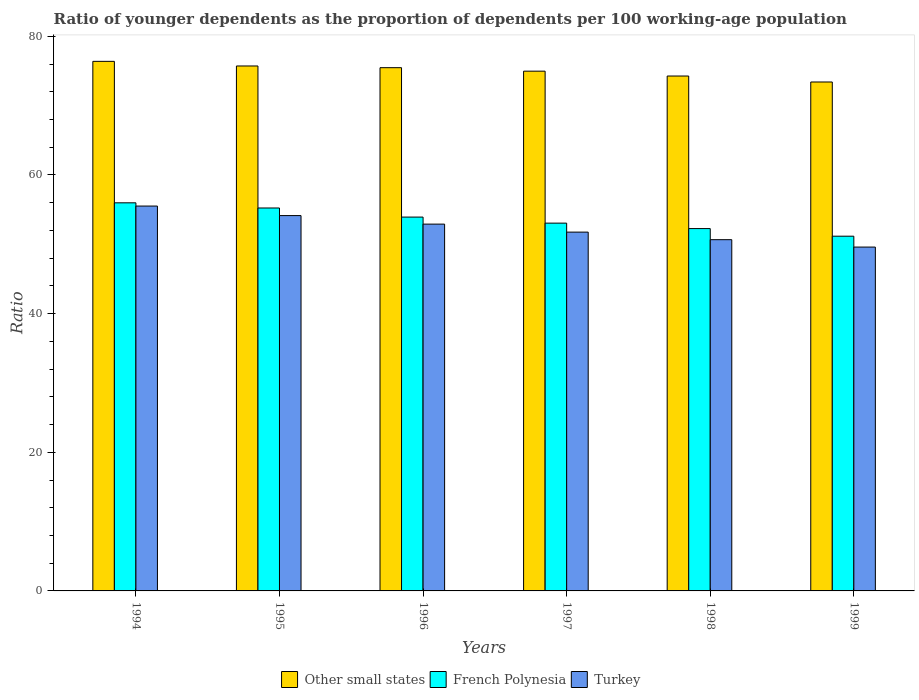How many groups of bars are there?
Offer a very short reply. 6. Are the number of bars on each tick of the X-axis equal?
Your response must be concise. Yes. How many bars are there on the 1st tick from the left?
Your answer should be compact. 3. What is the label of the 1st group of bars from the left?
Offer a terse response. 1994. In how many cases, is the number of bars for a given year not equal to the number of legend labels?
Offer a terse response. 0. What is the age dependency ratio(young) in Turkey in 1997?
Give a very brief answer. 51.76. Across all years, what is the maximum age dependency ratio(young) in Other small states?
Offer a terse response. 76.39. Across all years, what is the minimum age dependency ratio(young) in Other small states?
Keep it short and to the point. 73.42. In which year was the age dependency ratio(young) in French Polynesia minimum?
Keep it short and to the point. 1999. What is the total age dependency ratio(young) in French Polynesia in the graph?
Make the answer very short. 321.65. What is the difference between the age dependency ratio(young) in Other small states in 1995 and that in 1998?
Offer a terse response. 1.45. What is the difference between the age dependency ratio(young) in Turkey in 1998 and the age dependency ratio(young) in Other small states in 1999?
Offer a very short reply. -22.75. What is the average age dependency ratio(young) in Turkey per year?
Offer a very short reply. 52.43. In the year 1996, what is the difference between the age dependency ratio(young) in French Polynesia and age dependency ratio(young) in Other small states?
Keep it short and to the point. -21.55. What is the ratio of the age dependency ratio(young) in Other small states in 1996 to that in 1997?
Your response must be concise. 1.01. What is the difference between the highest and the second highest age dependency ratio(young) in Other small states?
Keep it short and to the point. 0.67. What is the difference between the highest and the lowest age dependency ratio(young) in French Polynesia?
Offer a very short reply. 4.81. Is the sum of the age dependency ratio(young) in French Polynesia in 1996 and 1999 greater than the maximum age dependency ratio(young) in Turkey across all years?
Keep it short and to the point. Yes. What does the 1st bar from the left in 1994 represents?
Offer a terse response. Other small states. What does the 1st bar from the right in 1994 represents?
Make the answer very short. Turkey. Is it the case that in every year, the sum of the age dependency ratio(young) in Other small states and age dependency ratio(young) in French Polynesia is greater than the age dependency ratio(young) in Turkey?
Give a very brief answer. Yes. Are all the bars in the graph horizontal?
Provide a succinct answer. No. What is the difference between two consecutive major ticks on the Y-axis?
Your answer should be compact. 20. Does the graph contain any zero values?
Your answer should be very brief. No. Does the graph contain grids?
Ensure brevity in your answer.  No. Where does the legend appear in the graph?
Your answer should be compact. Bottom center. How are the legend labels stacked?
Provide a short and direct response. Horizontal. What is the title of the graph?
Your response must be concise. Ratio of younger dependents as the proportion of dependents per 100 working-age population. What is the label or title of the Y-axis?
Provide a short and direct response. Ratio. What is the Ratio of Other small states in 1994?
Provide a succinct answer. 76.39. What is the Ratio in French Polynesia in 1994?
Your answer should be very brief. 55.99. What is the Ratio of Turkey in 1994?
Your response must be concise. 55.52. What is the Ratio of Other small states in 1995?
Offer a terse response. 75.73. What is the Ratio of French Polynesia in 1995?
Make the answer very short. 55.24. What is the Ratio in Turkey in 1995?
Your answer should be compact. 54.14. What is the Ratio of Other small states in 1996?
Give a very brief answer. 75.48. What is the Ratio of French Polynesia in 1996?
Offer a very short reply. 53.93. What is the Ratio in Turkey in 1996?
Your answer should be very brief. 52.91. What is the Ratio in Other small states in 1997?
Offer a very short reply. 74.98. What is the Ratio of French Polynesia in 1997?
Provide a short and direct response. 53.06. What is the Ratio in Turkey in 1997?
Provide a short and direct response. 51.76. What is the Ratio of Other small states in 1998?
Keep it short and to the point. 74.28. What is the Ratio of French Polynesia in 1998?
Offer a terse response. 52.27. What is the Ratio of Turkey in 1998?
Your answer should be very brief. 50.67. What is the Ratio in Other small states in 1999?
Provide a short and direct response. 73.42. What is the Ratio in French Polynesia in 1999?
Offer a terse response. 51.17. What is the Ratio of Turkey in 1999?
Make the answer very short. 49.6. Across all years, what is the maximum Ratio of Other small states?
Keep it short and to the point. 76.39. Across all years, what is the maximum Ratio of French Polynesia?
Ensure brevity in your answer.  55.99. Across all years, what is the maximum Ratio in Turkey?
Keep it short and to the point. 55.52. Across all years, what is the minimum Ratio in Other small states?
Offer a very short reply. 73.42. Across all years, what is the minimum Ratio of French Polynesia?
Your answer should be compact. 51.17. Across all years, what is the minimum Ratio of Turkey?
Your answer should be compact. 49.6. What is the total Ratio in Other small states in the graph?
Your answer should be compact. 450.28. What is the total Ratio of French Polynesia in the graph?
Keep it short and to the point. 321.65. What is the total Ratio in Turkey in the graph?
Offer a very short reply. 314.61. What is the difference between the Ratio in Other small states in 1994 and that in 1995?
Ensure brevity in your answer.  0.67. What is the difference between the Ratio of French Polynesia in 1994 and that in 1995?
Provide a short and direct response. 0.74. What is the difference between the Ratio of Turkey in 1994 and that in 1995?
Ensure brevity in your answer.  1.37. What is the difference between the Ratio in Other small states in 1994 and that in 1996?
Ensure brevity in your answer.  0.91. What is the difference between the Ratio of French Polynesia in 1994 and that in 1996?
Offer a very short reply. 2.06. What is the difference between the Ratio in Turkey in 1994 and that in 1996?
Offer a terse response. 2.61. What is the difference between the Ratio in Other small states in 1994 and that in 1997?
Offer a terse response. 1.42. What is the difference between the Ratio of French Polynesia in 1994 and that in 1997?
Provide a succinct answer. 2.93. What is the difference between the Ratio in Turkey in 1994 and that in 1997?
Your response must be concise. 3.76. What is the difference between the Ratio in Other small states in 1994 and that in 1998?
Make the answer very short. 2.12. What is the difference between the Ratio of French Polynesia in 1994 and that in 1998?
Provide a succinct answer. 3.72. What is the difference between the Ratio in Turkey in 1994 and that in 1998?
Your answer should be very brief. 4.85. What is the difference between the Ratio in Other small states in 1994 and that in 1999?
Keep it short and to the point. 2.98. What is the difference between the Ratio of French Polynesia in 1994 and that in 1999?
Your response must be concise. 4.81. What is the difference between the Ratio of Turkey in 1994 and that in 1999?
Your response must be concise. 5.92. What is the difference between the Ratio in Other small states in 1995 and that in 1996?
Ensure brevity in your answer.  0.25. What is the difference between the Ratio in French Polynesia in 1995 and that in 1996?
Keep it short and to the point. 1.31. What is the difference between the Ratio in Turkey in 1995 and that in 1996?
Provide a succinct answer. 1.23. What is the difference between the Ratio of Other small states in 1995 and that in 1997?
Your response must be concise. 0.75. What is the difference between the Ratio in French Polynesia in 1995 and that in 1997?
Offer a terse response. 2.19. What is the difference between the Ratio of Turkey in 1995 and that in 1997?
Give a very brief answer. 2.38. What is the difference between the Ratio of Other small states in 1995 and that in 1998?
Ensure brevity in your answer.  1.45. What is the difference between the Ratio in French Polynesia in 1995 and that in 1998?
Your answer should be compact. 2.97. What is the difference between the Ratio in Turkey in 1995 and that in 1998?
Your response must be concise. 3.48. What is the difference between the Ratio of Other small states in 1995 and that in 1999?
Provide a short and direct response. 2.31. What is the difference between the Ratio in French Polynesia in 1995 and that in 1999?
Offer a terse response. 4.07. What is the difference between the Ratio in Turkey in 1995 and that in 1999?
Keep it short and to the point. 4.54. What is the difference between the Ratio of Other small states in 1996 and that in 1997?
Provide a succinct answer. 0.5. What is the difference between the Ratio in French Polynesia in 1996 and that in 1997?
Ensure brevity in your answer.  0.87. What is the difference between the Ratio in Turkey in 1996 and that in 1997?
Offer a very short reply. 1.15. What is the difference between the Ratio of Other small states in 1996 and that in 1998?
Provide a short and direct response. 1.2. What is the difference between the Ratio of French Polynesia in 1996 and that in 1998?
Your answer should be very brief. 1.66. What is the difference between the Ratio in Turkey in 1996 and that in 1998?
Offer a very short reply. 2.24. What is the difference between the Ratio in Other small states in 1996 and that in 1999?
Your response must be concise. 2.06. What is the difference between the Ratio of French Polynesia in 1996 and that in 1999?
Your answer should be compact. 2.76. What is the difference between the Ratio in Turkey in 1996 and that in 1999?
Provide a succinct answer. 3.31. What is the difference between the Ratio in Other small states in 1997 and that in 1998?
Give a very brief answer. 0.7. What is the difference between the Ratio in French Polynesia in 1997 and that in 1998?
Your response must be concise. 0.79. What is the difference between the Ratio in Turkey in 1997 and that in 1998?
Your answer should be very brief. 1.09. What is the difference between the Ratio of Other small states in 1997 and that in 1999?
Your answer should be compact. 1.56. What is the difference between the Ratio in French Polynesia in 1997 and that in 1999?
Your answer should be compact. 1.88. What is the difference between the Ratio in Turkey in 1997 and that in 1999?
Offer a very short reply. 2.16. What is the difference between the Ratio in Other small states in 1998 and that in 1999?
Your answer should be very brief. 0.86. What is the difference between the Ratio in French Polynesia in 1998 and that in 1999?
Make the answer very short. 1.1. What is the difference between the Ratio in Turkey in 1998 and that in 1999?
Offer a very short reply. 1.07. What is the difference between the Ratio in Other small states in 1994 and the Ratio in French Polynesia in 1995?
Offer a terse response. 21.15. What is the difference between the Ratio of Other small states in 1994 and the Ratio of Turkey in 1995?
Give a very brief answer. 22.25. What is the difference between the Ratio in French Polynesia in 1994 and the Ratio in Turkey in 1995?
Provide a short and direct response. 1.84. What is the difference between the Ratio of Other small states in 1994 and the Ratio of French Polynesia in 1996?
Provide a short and direct response. 22.47. What is the difference between the Ratio in Other small states in 1994 and the Ratio in Turkey in 1996?
Ensure brevity in your answer.  23.48. What is the difference between the Ratio in French Polynesia in 1994 and the Ratio in Turkey in 1996?
Offer a terse response. 3.07. What is the difference between the Ratio in Other small states in 1994 and the Ratio in French Polynesia in 1997?
Your answer should be very brief. 23.34. What is the difference between the Ratio of Other small states in 1994 and the Ratio of Turkey in 1997?
Provide a short and direct response. 24.63. What is the difference between the Ratio of French Polynesia in 1994 and the Ratio of Turkey in 1997?
Your response must be concise. 4.22. What is the difference between the Ratio of Other small states in 1994 and the Ratio of French Polynesia in 1998?
Ensure brevity in your answer.  24.13. What is the difference between the Ratio in Other small states in 1994 and the Ratio in Turkey in 1998?
Offer a terse response. 25.73. What is the difference between the Ratio in French Polynesia in 1994 and the Ratio in Turkey in 1998?
Provide a short and direct response. 5.32. What is the difference between the Ratio of Other small states in 1994 and the Ratio of French Polynesia in 1999?
Your answer should be compact. 25.22. What is the difference between the Ratio of Other small states in 1994 and the Ratio of Turkey in 1999?
Keep it short and to the point. 26.79. What is the difference between the Ratio in French Polynesia in 1994 and the Ratio in Turkey in 1999?
Provide a short and direct response. 6.38. What is the difference between the Ratio of Other small states in 1995 and the Ratio of French Polynesia in 1996?
Provide a succinct answer. 21.8. What is the difference between the Ratio of Other small states in 1995 and the Ratio of Turkey in 1996?
Make the answer very short. 22.81. What is the difference between the Ratio in French Polynesia in 1995 and the Ratio in Turkey in 1996?
Keep it short and to the point. 2.33. What is the difference between the Ratio of Other small states in 1995 and the Ratio of French Polynesia in 1997?
Provide a short and direct response. 22.67. What is the difference between the Ratio in Other small states in 1995 and the Ratio in Turkey in 1997?
Give a very brief answer. 23.97. What is the difference between the Ratio of French Polynesia in 1995 and the Ratio of Turkey in 1997?
Your answer should be very brief. 3.48. What is the difference between the Ratio of Other small states in 1995 and the Ratio of French Polynesia in 1998?
Provide a succinct answer. 23.46. What is the difference between the Ratio of Other small states in 1995 and the Ratio of Turkey in 1998?
Make the answer very short. 25.06. What is the difference between the Ratio in French Polynesia in 1995 and the Ratio in Turkey in 1998?
Offer a very short reply. 4.57. What is the difference between the Ratio of Other small states in 1995 and the Ratio of French Polynesia in 1999?
Provide a succinct answer. 24.56. What is the difference between the Ratio of Other small states in 1995 and the Ratio of Turkey in 1999?
Provide a short and direct response. 26.12. What is the difference between the Ratio in French Polynesia in 1995 and the Ratio in Turkey in 1999?
Make the answer very short. 5.64. What is the difference between the Ratio in Other small states in 1996 and the Ratio in French Polynesia in 1997?
Your response must be concise. 22.43. What is the difference between the Ratio in Other small states in 1996 and the Ratio in Turkey in 1997?
Provide a succinct answer. 23.72. What is the difference between the Ratio in French Polynesia in 1996 and the Ratio in Turkey in 1997?
Offer a terse response. 2.17. What is the difference between the Ratio in Other small states in 1996 and the Ratio in French Polynesia in 1998?
Provide a succinct answer. 23.21. What is the difference between the Ratio of Other small states in 1996 and the Ratio of Turkey in 1998?
Your response must be concise. 24.81. What is the difference between the Ratio of French Polynesia in 1996 and the Ratio of Turkey in 1998?
Provide a short and direct response. 3.26. What is the difference between the Ratio of Other small states in 1996 and the Ratio of French Polynesia in 1999?
Provide a short and direct response. 24.31. What is the difference between the Ratio in Other small states in 1996 and the Ratio in Turkey in 1999?
Your answer should be very brief. 25.88. What is the difference between the Ratio in French Polynesia in 1996 and the Ratio in Turkey in 1999?
Your answer should be very brief. 4.33. What is the difference between the Ratio in Other small states in 1997 and the Ratio in French Polynesia in 1998?
Your answer should be compact. 22.71. What is the difference between the Ratio in Other small states in 1997 and the Ratio in Turkey in 1998?
Provide a short and direct response. 24.31. What is the difference between the Ratio of French Polynesia in 1997 and the Ratio of Turkey in 1998?
Provide a succinct answer. 2.39. What is the difference between the Ratio in Other small states in 1997 and the Ratio in French Polynesia in 1999?
Ensure brevity in your answer.  23.81. What is the difference between the Ratio in Other small states in 1997 and the Ratio in Turkey in 1999?
Give a very brief answer. 25.38. What is the difference between the Ratio of French Polynesia in 1997 and the Ratio of Turkey in 1999?
Provide a short and direct response. 3.45. What is the difference between the Ratio of Other small states in 1998 and the Ratio of French Polynesia in 1999?
Provide a succinct answer. 23.11. What is the difference between the Ratio of Other small states in 1998 and the Ratio of Turkey in 1999?
Give a very brief answer. 24.67. What is the difference between the Ratio in French Polynesia in 1998 and the Ratio in Turkey in 1999?
Your answer should be compact. 2.67. What is the average Ratio in Other small states per year?
Your answer should be very brief. 75.05. What is the average Ratio of French Polynesia per year?
Keep it short and to the point. 53.61. What is the average Ratio in Turkey per year?
Give a very brief answer. 52.43. In the year 1994, what is the difference between the Ratio of Other small states and Ratio of French Polynesia?
Your answer should be compact. 20.41. In the year 1994, what is the difference between the Ratio of Other small states and Ratio of Turkey?
Offer a very short reply. 20.87. In the year 1994, what is the difference between the Ratio in French Polynesia and Ratio in Turkey?
Your answer should be compact. 0.47. In the year 1995, what is the difference between the Ratio of Other small states and Ratio of French Polynesia?
Make the answer very short. 20.49. In the year 1995, what is the difference between the Ratio in Other small states and Ratio in Turkey?
Give a very brief answer. 21.58. In the year 1995, what is the difference between the Ratio of French Polynesia and Ratio of Turkey?
Provide a short and direct response. 1.1. In the year 1996, what is the difference between the Ratio of Other small states and Ratio of French Polynesia?
Offer a terse response. 21.55. In the year 1996, what is the difference between the Ratio in Other small states and Ratio in Turkey?
Offer a terse response. 22.57. In the year 1996, what is the difference between the Ratio of French Polynesia and Ratio of Turkey?
Make the answer very short. 1.02. In the year 1997, what is the difference between the Ratio in Other small states and Ratio in French Polynesia?
Give a very brief answer. 21.92. In the year 1997, what is the difference between the Ratio of Other small states and Ratio of Turkey?
Your answer should be very brief. 23.22. In the year 1997, what is the difference between the Ratio of French Polynesia and Ratio of Turkey?
Ensure brevity in your answer.  1.29. In the year 1998, what is the difference between the Ratio of Other small states and Ratio of French Polynesia?
Your answer should be very brief. 22.01. In the year 1998, what is the difference between the Ratio of Other small states and Ratio of Turkey?
Your answer should be very brief. 23.61. In the year 1998, what is the difference between the Ratio of French Polynesia and Ratio of Turkey?
Your response must be concise. 1.6. In the year 1999, what is the difference between the Ratio of Other small states and Ratio of French Polynesia?
Provide a succinct answer. 22.25. In the year 1999, what is the difference between the Ratio in Other small states and Ratio in Turkey?
Give a very brief answer. 23.81. In the year 1999, what is the difference between the Ratio of French Polynesia and Ratio of Turkey?
Provide a short and direct response. 1.57. What is the ratio of the Ratio in Other small states in 1994 to that in 1995?
Keep it short and to the point. 1.01. What is the ratio of the Ratio of French Polynesia in 1994 to that in 1995?
Your answer should be very brief. 1.01. What is the ratio of the Ratio in Turkey in 1994 to that in 1995?
Provide a short and direct response. 1.03. What is the ratio of the Ratio of Other small states in 1994 to that in 1996?
Provide a short and direct response. 1.01. What is the ratio of the Ratio in French Polynesia in 1994 to that in 1996?
Your response must be concise. 1.04. What is the ratio of the Ratio of Turkey in 1994 to that in 1996?
Offer a terse response. 1.05. What is the ratio of the Ratio of Other small states in 1994 to that in 1997?
Your response must be concise. 1.02. What is the ratio of the Ratio in French Polynesia in 1994 to that in 1997?
Your response must be concise. 1.06. What is the ratio of the Ratio of Turkey in 1994 to that in 1997?
Give a very brief answer. 1.07. What is the ratio of the Ratio of Other small states in 1994 to that in 1998?
Ensure brevity in your answer.  1.03. What is the ratio of the Ratio of French Polynesia in 1994 to that in 1998?
Your answer should be very brief. 1.07. What is the ratio of the Ratio of Turkey in 1994 to that in 1998?
Make the answer very short. 1.1. What is the ratio of the Ratio in Other small states in 1994 to that in 1999?
Your answer should be compact. 1.04. What is the ratio of the Ratio in French Polynesia in 1994 to that in 1999?
Provide a short and direct response. 1.09. What is the ratio of the Ratio of Turkey in 1994 to that in 1999?
Your response must be concise. 1.12. What is the ratio of the Ratio in Other small states in 1995 to that in 1996?
Keep it short and to the point. 1. What is the ratio of the Ratio of French Polynesia in 1995 to that in 1996?
Your answer should be very brief. 1.02. What is the ratio of the Ratio in Turkey in 1995 to that in 1996?
Provide a succinct answer. 1.02. What is the ratio of the Ratio of French Polynesia in 1995 to that in 1997?
Provide a succinct answer. 1.04. What is the ratio of the Ratio in Turkey in 1995 to that in 1997?
Give a very brief answer. 1.05. What is the ratio of the Ratio of Other small states in 1995 to that in 1998?
Offer a very short reply. 1.02. What is the ratio of the Ratio of French Polynesia in 1995 to that in 1998?
Give a very brief answer. 1.06. What is the ratio of the Ratio of Turkey in 1995 to that in 1998?
Offer a terse response. 1.07. What is the ratio of the Ratio in Other small states in 1995 to that in 1999?
Provide a succinct answer. 1.03. What is the ratio of the Ratio in French Polynesia in 1995 to that in 1999?
Make the answer very short. 1.08. What is the ratio of the Ratio of Turkey in 1995 to that in 1999?
Offer a terse response. 1.09. What is the ratio of the Ratio of French Polynesia in 1996 to that in 1997?
Offer a very short reply. 1.02. What is the ratio of the Ratio in Turkey in 1996 to that in 1997?
Provide a short and direct response. 1.02. What is the ratio of the Ratio of Other small states in 1996 to that in 1998?
Keep it short and to the point. 1.02. What is the ratio of the Ratio of French Polynesia in 1996 to that in 1998?
Your answer should be very brief. 1.03. What is the ratio of the Ratio of Turkey in 1996 to that in 1998?
Your response must be concise. 1.04. What is the ratio of the Ratio of Other small states in 1996 to that in 1999?
Ensure brevity in your answer.  1.03. What is the ratio of the Ratio in French Polynesia in 1996 to that in 1999?
Keep it short and to the point. 1.05. What is the ratio of the Ratio of Turkey in 1996 to that in 1999?
Offer a terse response. 1.07. What is the ratio of the Ratio of Other small states in 1997 to that in 1998?
Offer a very short reply. 1.01. What is the ratio of the Ratio in French Polynesia in 1997 to that in 1998?
Offer a very short reply. 1.02. What is the ratio of the Ratio of Turkey in 1997 to that in 1998?
Your response must be concise. 1.02. What is the ratio of the Ratio of Other small states in 1997 to that in 1999?
Keep it short and to the point. 1.02. What is the ratio of the Ratio of French Polynesia in 1997 to that in 1999?
Your answer should be compact. 1.04. What is the ratio of the Ratio of Turkey in 1997 to that in 1999?
Offer a terse response. 1.04. What is the ratio of the Ratio of Other small states in 1998 to that in 1999?
Keep it short and to the point. 1.01. What is the ratio of the Ratio in French Polynesia in 1998 to that in 1999?
Give a very brief answer. 1.02. What is the ratio of the Ratio of Turkey in 1998 to that in 1999?
Provide a short and direct response. 1.02. What is the difference between the highest and the second highest Ratio in Other small states?
Provide a short and direct response. 0.67. What is the difference between the highest and the second highest Ratio of French Polynesia?
Your answer should be very brief. 0.74. What is the difference between the highest and the second highest Ratio of Turkey?
Your response must be concise. 1.37. What is the difference between the highest and the lowest Ratio in Other small states?
Provide a succinct answer. 2.98. What is the difference between the highest and the lowest Ratio of French Polynesia?
Your answer should be very brief. 4.81. What is the difference between the highest and the lowest Ratio in Turkey?
Offer a very short reply. 5.92. 